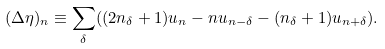Convert formula to latex. <formula><loc_0><loc_0><loc_500><loc_500>( \Delta \eta ) _ { n } \equiv \sum _ { \delta } ( ( 2 n _ { \delta } + 1 ) u _ { n } - n u _ { n - \delta } - ( n _ { \delta } + 1 ) u _ { n + \delta } ) .</formula> 